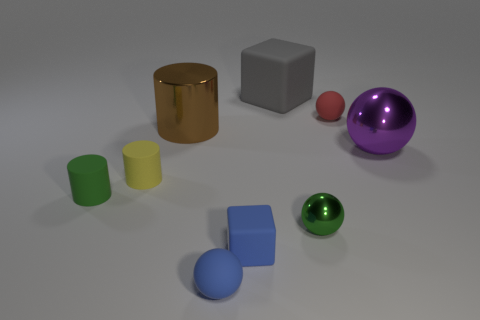Subtract 1 balls. How many balls are left? 3 Subtract all blue balls. How many balls are left? 3 Subtract all brown spheres. Subtract all gray cubes. How many spheres are left? 4 Add 3 tiny green cylinders. How many tiny green cylinders exist? 4 Subtract 0 green blocks. How many objects are left? 9 Subtract all cubes. How many objects are left? 7 Subtract all tiny matte blocks. Subtract all big cylinders. How many objects are left? 7 Add 8 purple shiny objects. How many purple shiny objects are left? 9 